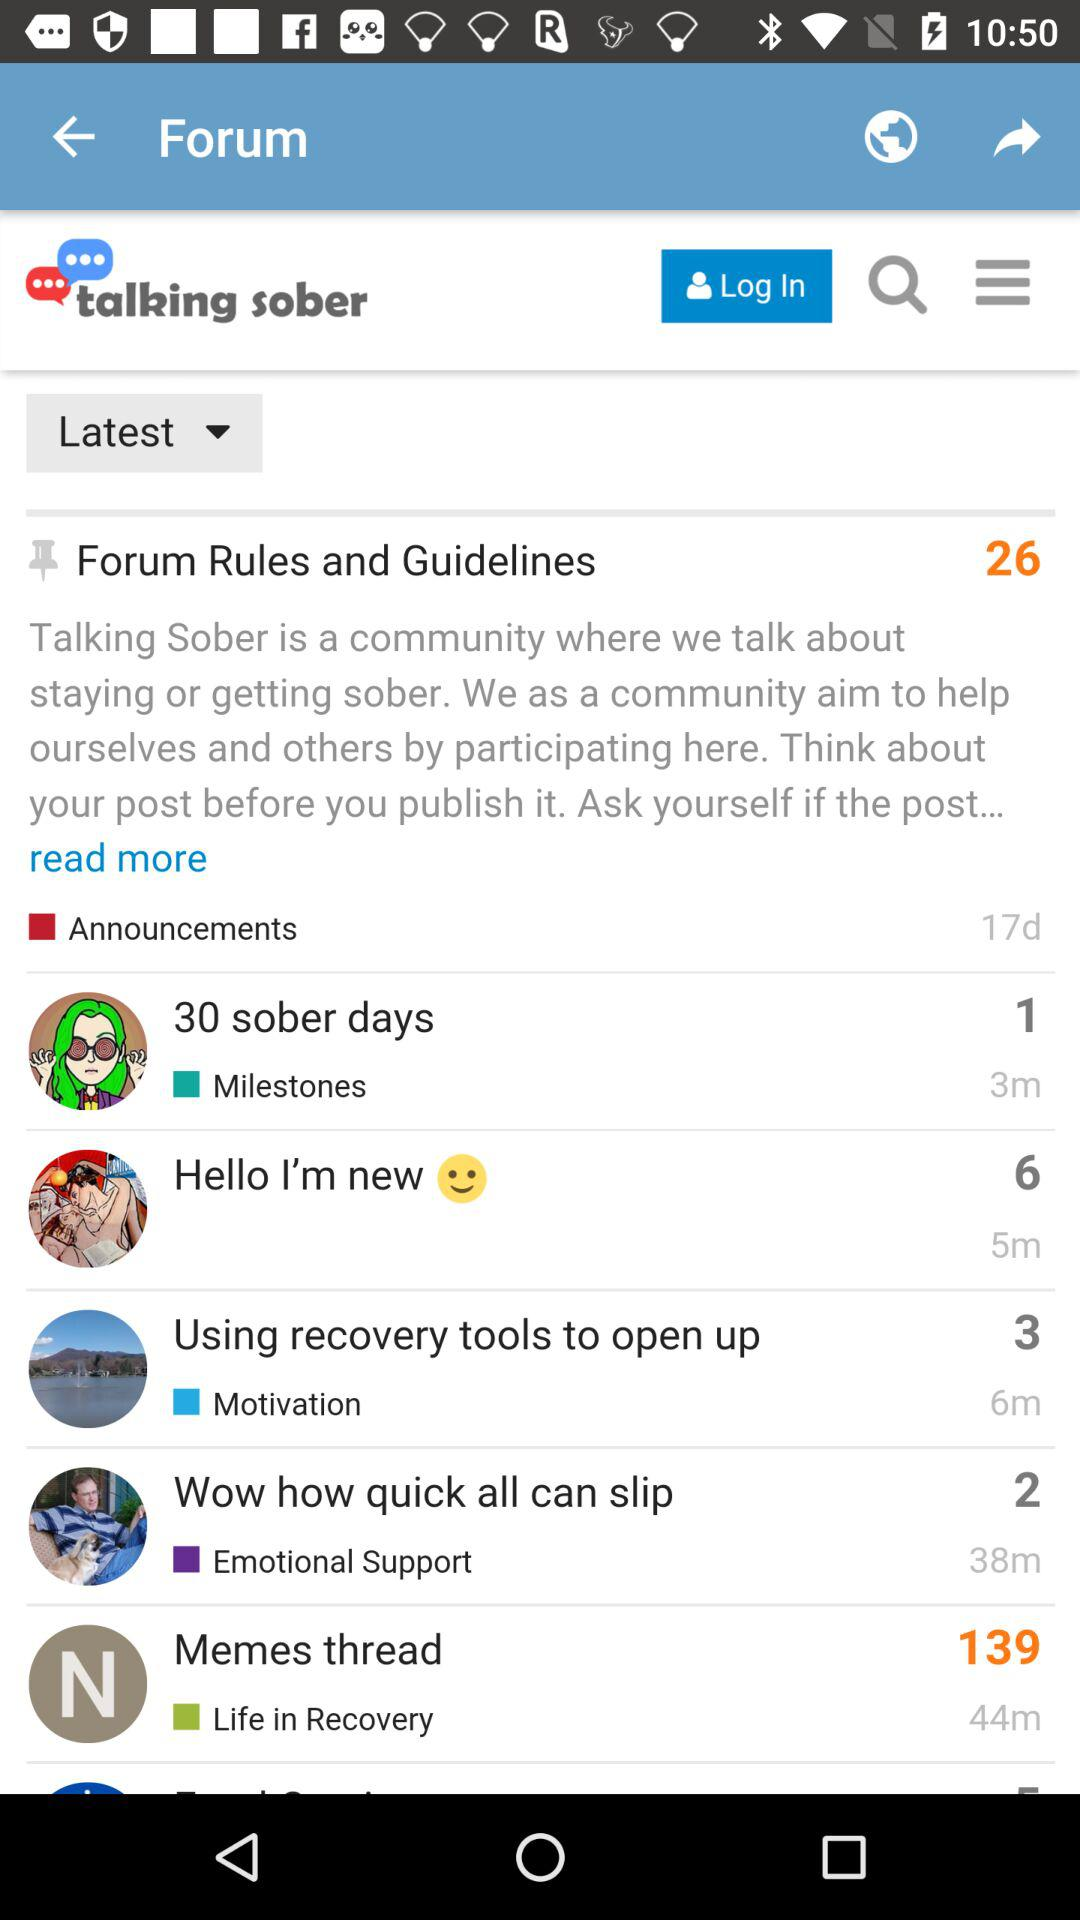What is the total number of forum rules and guidelines? The total number of forum rules and guidelines is 26. 